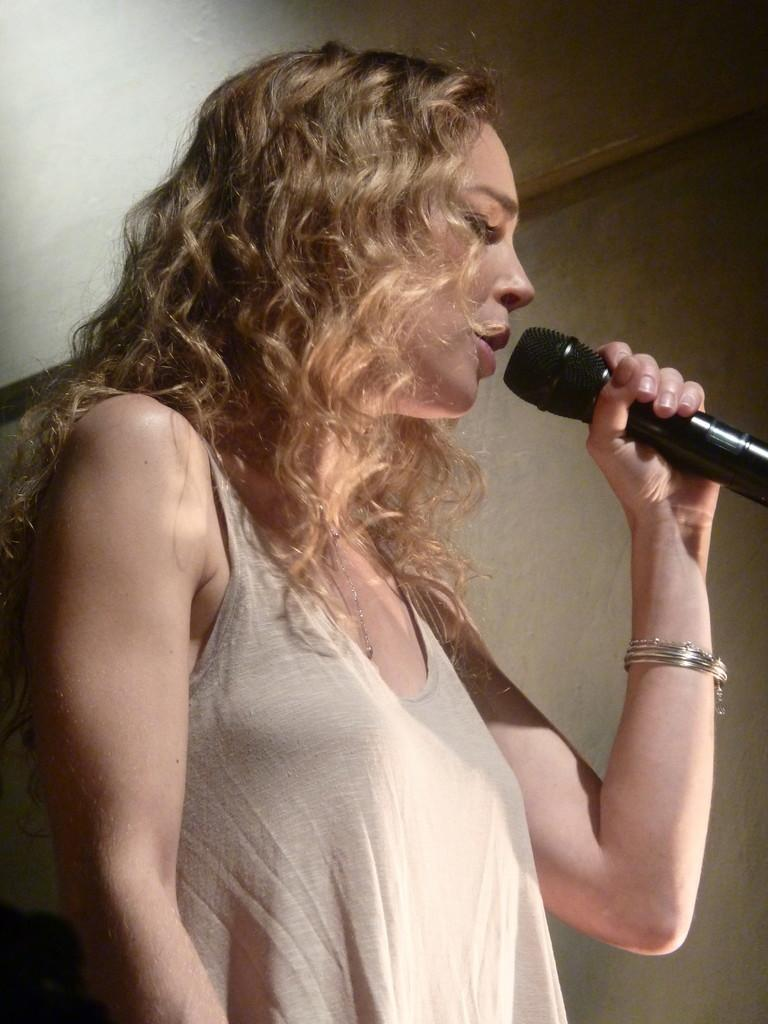Who is the main subject in the image? There is a woman in the image. What is the woman doing in the image? The woman is standing and singing. What object is the woman holding in her hand? The woman is holding a microphone in her hand. What type of jam is the woman spreading on the bear in the image? There is no jam or bear present in the image; it features a woman singing while holding a microphone. 